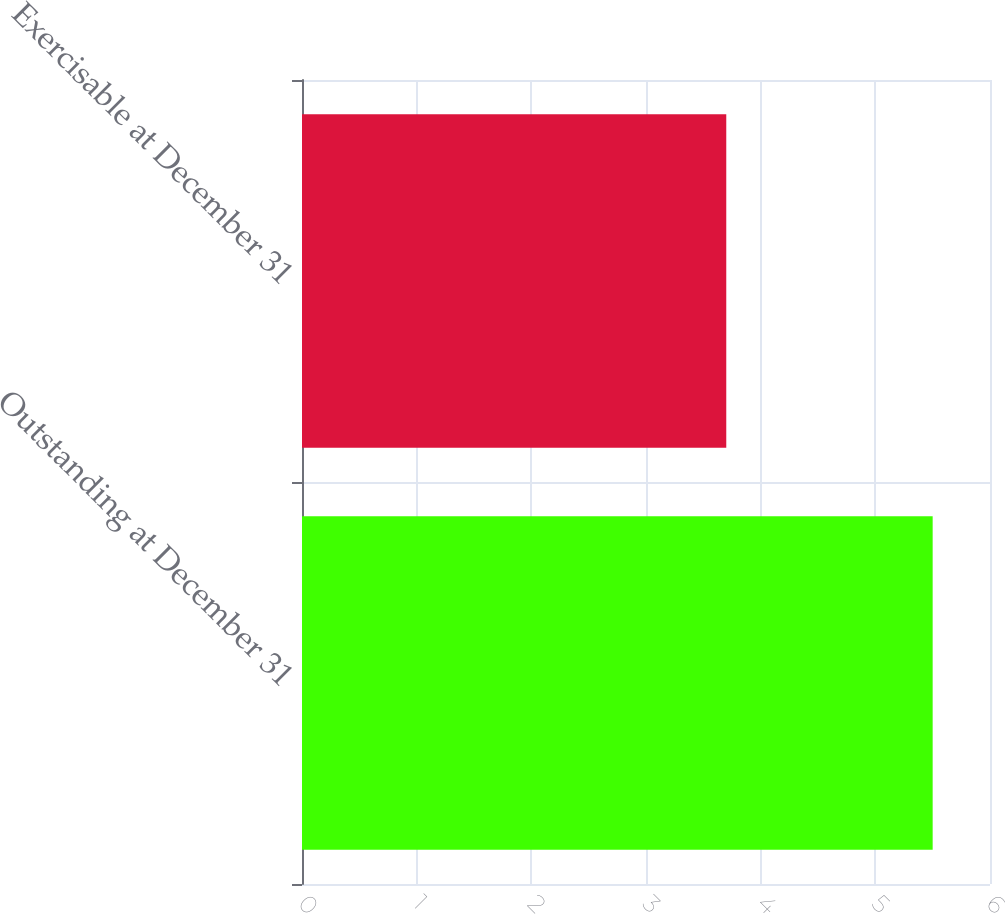Convert chart to OTSL. <chart><loc_0><loc_0><loc_500><loc_500><bar_chart><fcel>Outstanding at December 31<fcel>Exercisable at December 31<nl><fcel>5.5<fcel>3.7<nl></chart> 